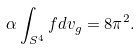<formula> <loc_0><loc_0><loc_500><loc_500>\alpha \int _ { S ^ { 4 } } f d v _ { g } = 8 \pi ^ { 2 } .</formula> 